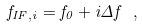<formula> <loc_0><loc_0><loc_500><loc_500>f _ { I F , i } = f _ { 0 } + i \Delta f \ ,</formula> 